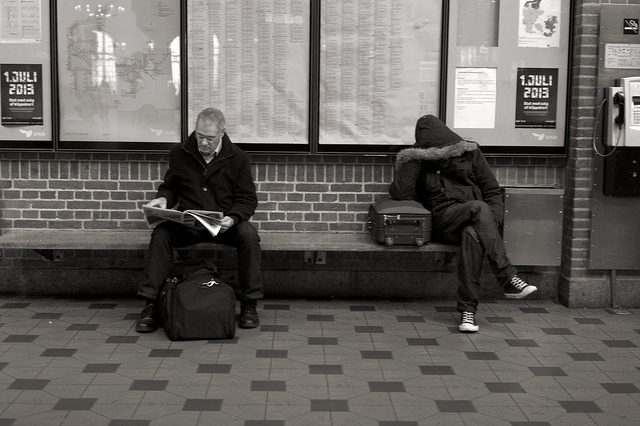Please transcribe the text in this image. 2013 JULI JULI 2013 1 1. 